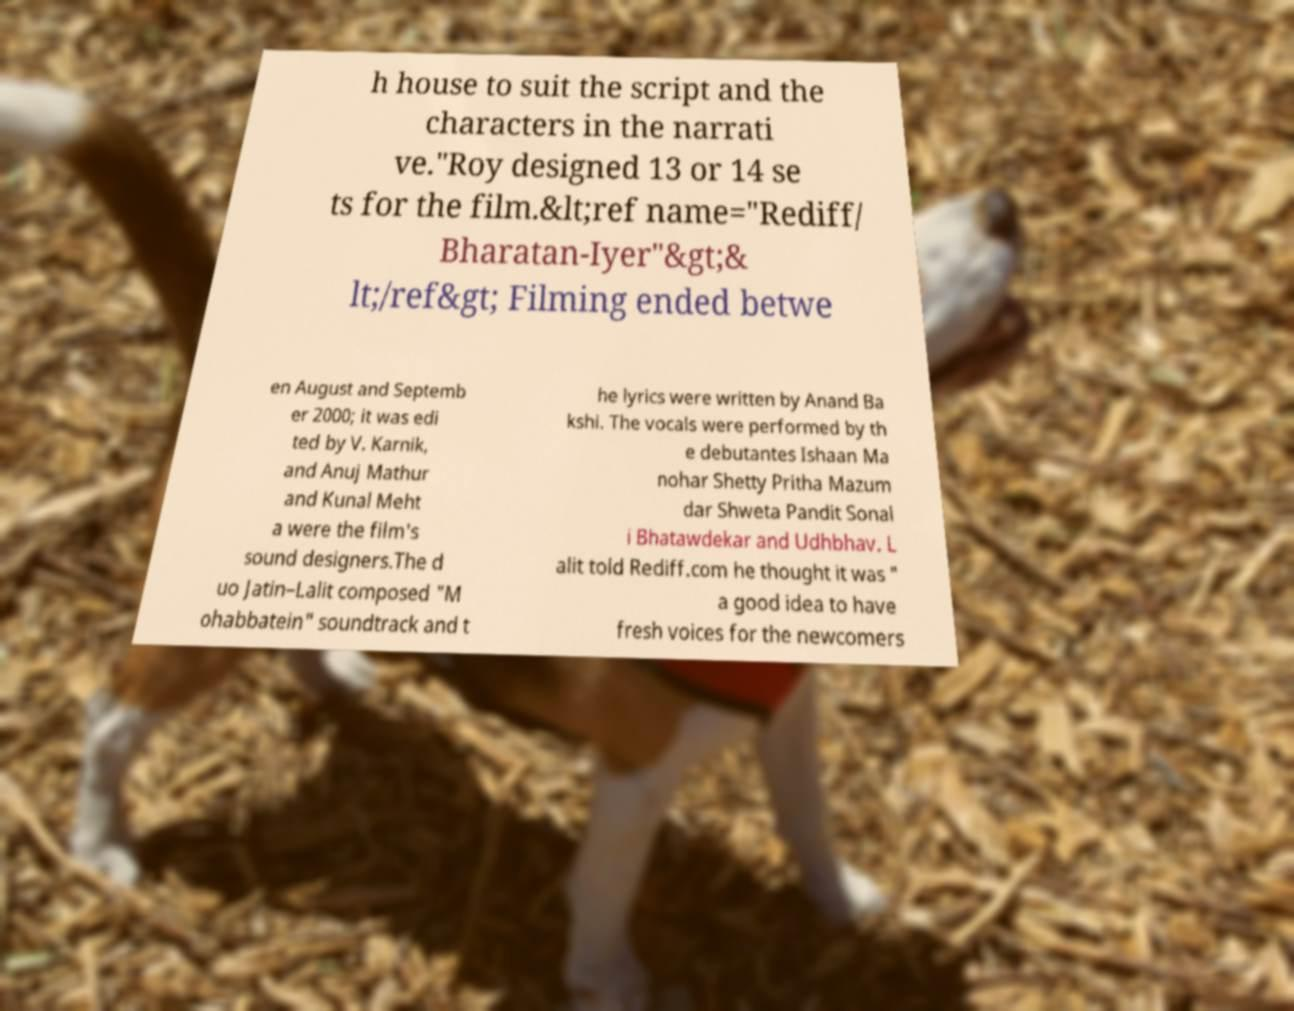I need the written content from this picture converted into text. Can you do that? h house to suit the script and the characters in the narrati ve."Roy designed 13 or 14 se ts for the film.&lt;ref name="Rediff/ Bharatan-Iyer"&gt;& lt;/ref&gt; Filming ended betwe en August and Septemb er 2000; it was edi ted by V. Karnik, and Anuj Mathur and Kunal Meht a were the film's sound designers.The d uo Jatin–Lalit composed "M ohabbatein" soundtrack and t he lyrics were written by Anand Ba kshi. The vocals were performed by th e debutantes Ishaan Ma nohar Shetty Pritha Mazum dar Shweta Pandit Sonal i Bhatawdekar and Udhbhav. L alit told Rediff.com he thought it was " a good idea to have fresh voices for the newcomers 